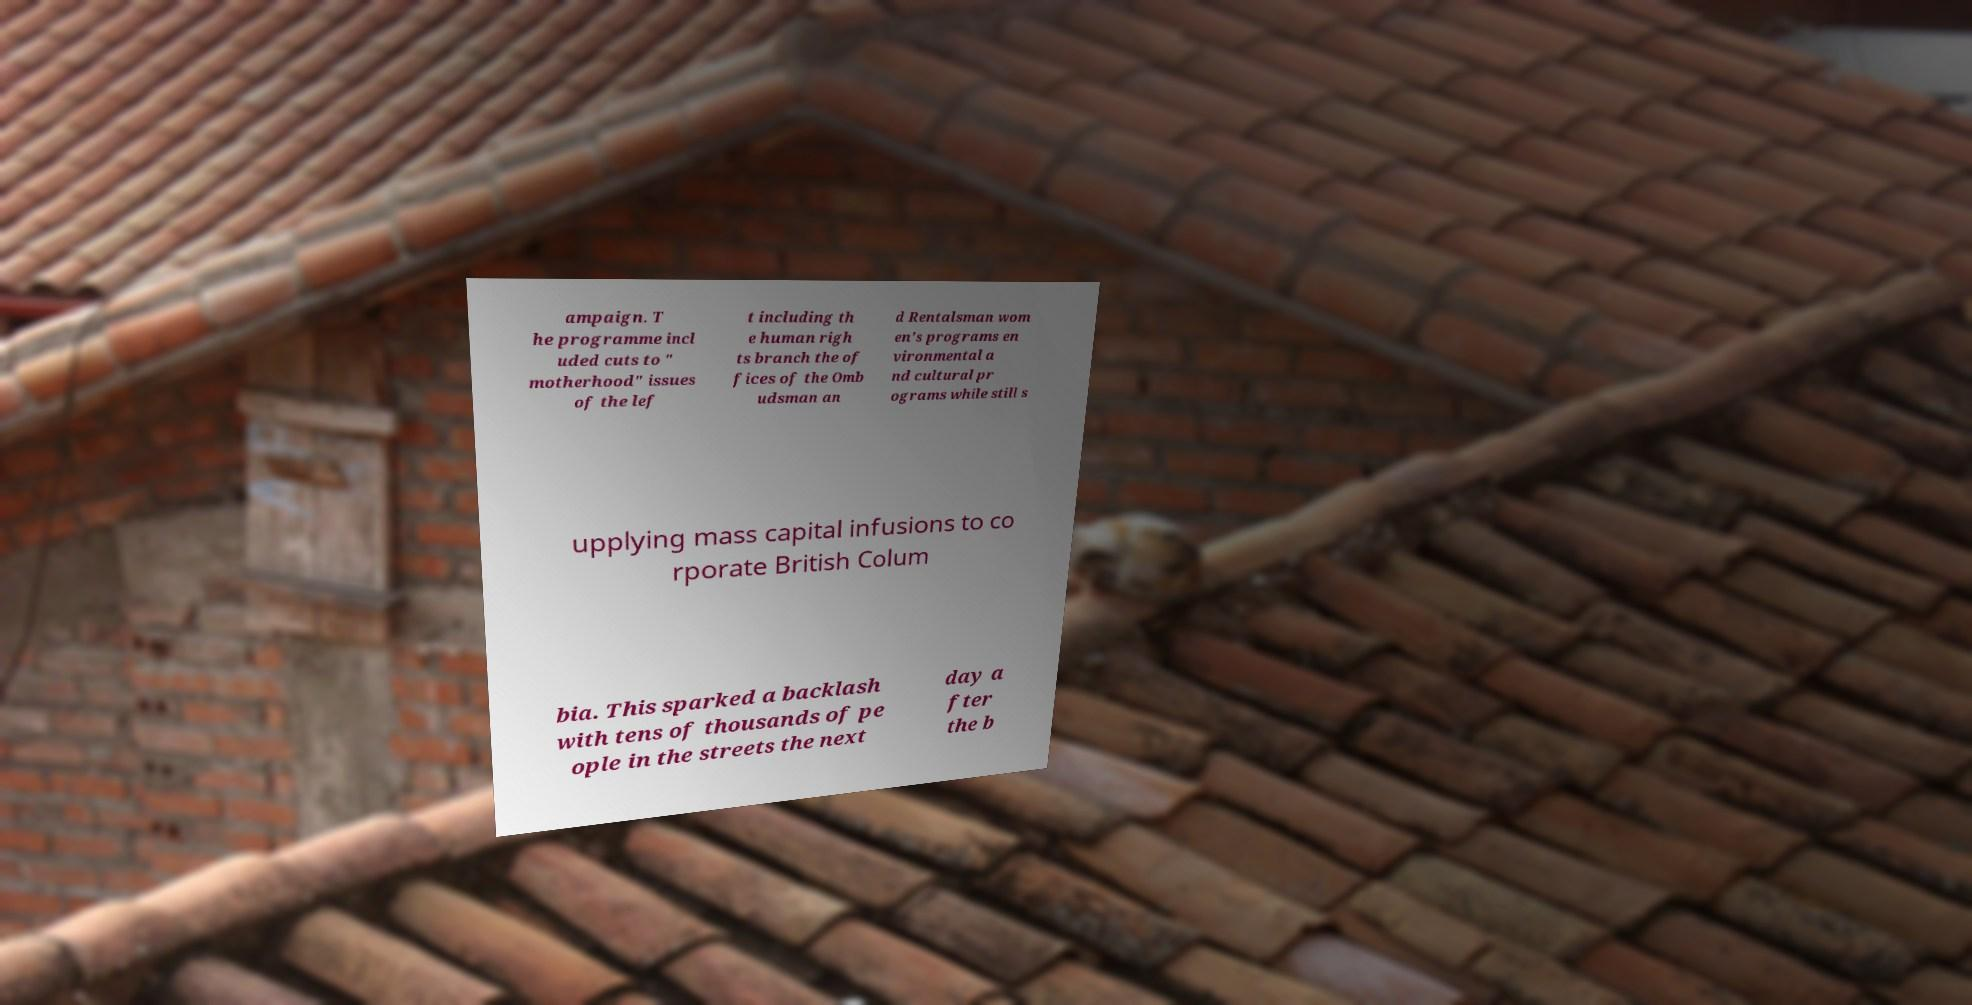Could you assist in decoding the text presented in this image and type it out clearly? ampaign. T he programme incl uded cuts to " motherhood" issues of the lef t including th e human righ ts branch the of fices of the Omb udsman an d Rentalsman wom en's programs en vironmental a nd cultural pr ograms while still s upplying mass capital infusions to co rporate British Colum bia. This sparked a backlash with tens of thousands of pe ople in the streets the next day a fter the b 